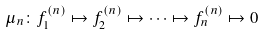Convert formula to latex. <formula><loc_0><loc_0><loc_500><loc_500>\mu _ { n } \colon f ^ { ( n ) } _ { 1 } \mapsto f ^ { ( n ) } _ { 2 } \mapsto \cdots \mapsto f ^ { ( n ) } _ { n } \mapsto 0</formula> 